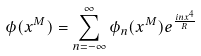<formula> <loc_0><loc_0><loc_500><loc_500>\phi ( x ^ { M } ) = \sum _ { n = - \infty } ^ { \infty } \phi _ { n } ( x ^ { M } ) e ^ { \frac { i n x ^ { 4 } } { R } }</formula> 